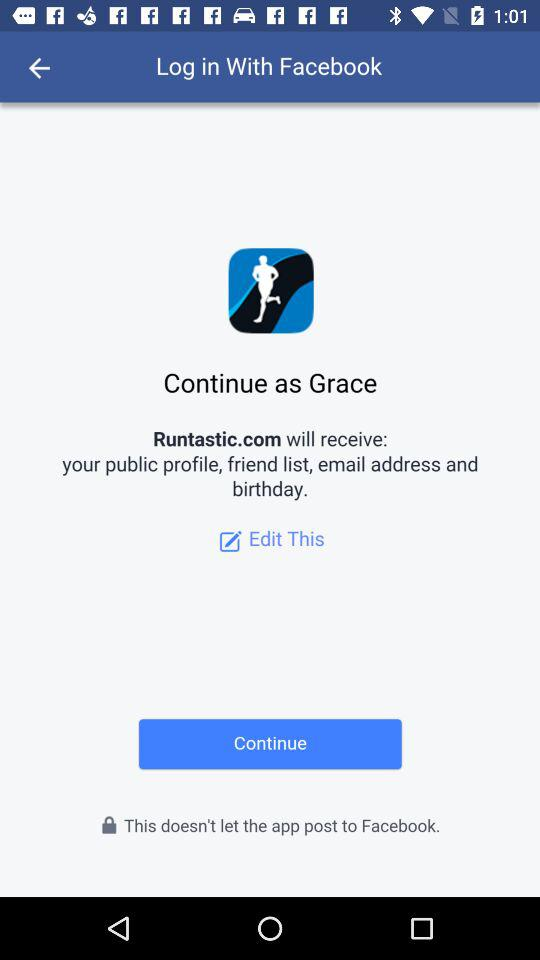What application will receive a public profile and email address? The application is "Runtastic.com". 